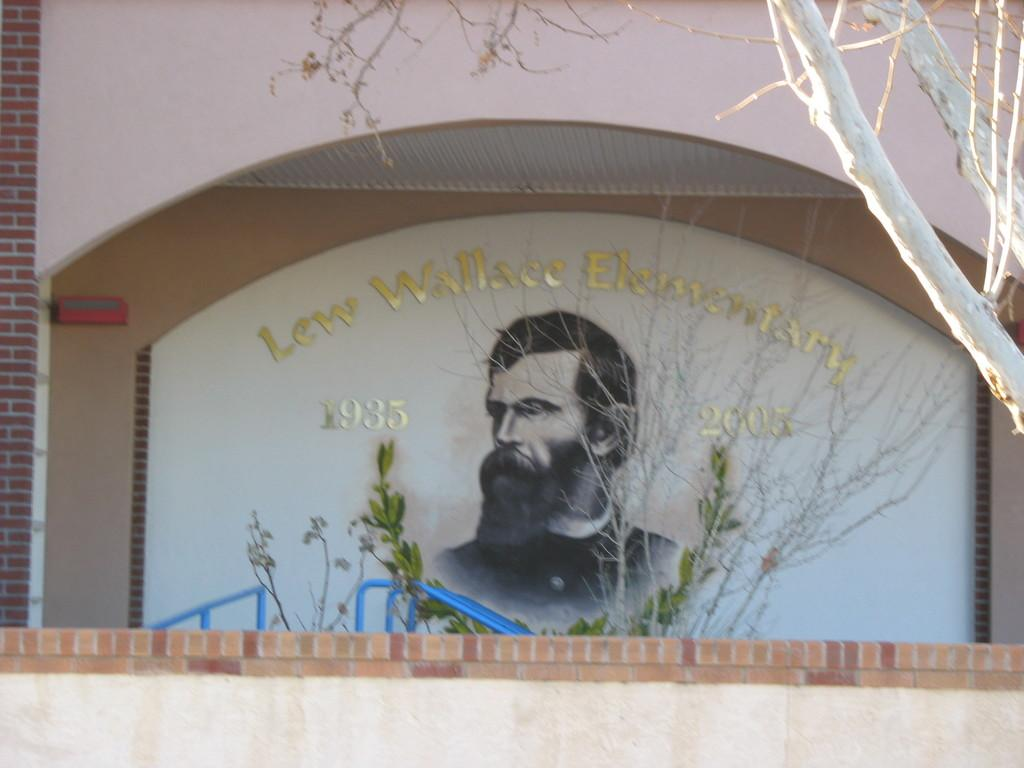What is depicted on the wall in the image? There is a painting of a person on the wall. What other elements can be seen in the image? There are plants in the image. What type of stomach pain is the person in the painting experiencing? There is no indication of any stomach pain in the image, as it only features a painting of a person and plants. 